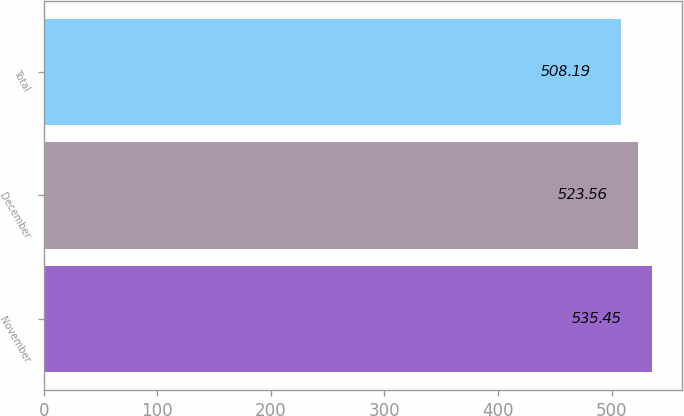Convert chart to OTSL. <chart><loc_0><loc_0><loc_500><loc_500><bar_chart><fcel>November<fcel>December<fcel>Total<nl><fcel>535.45<fcel>523.56<fcel>508.19<nl></chart> 